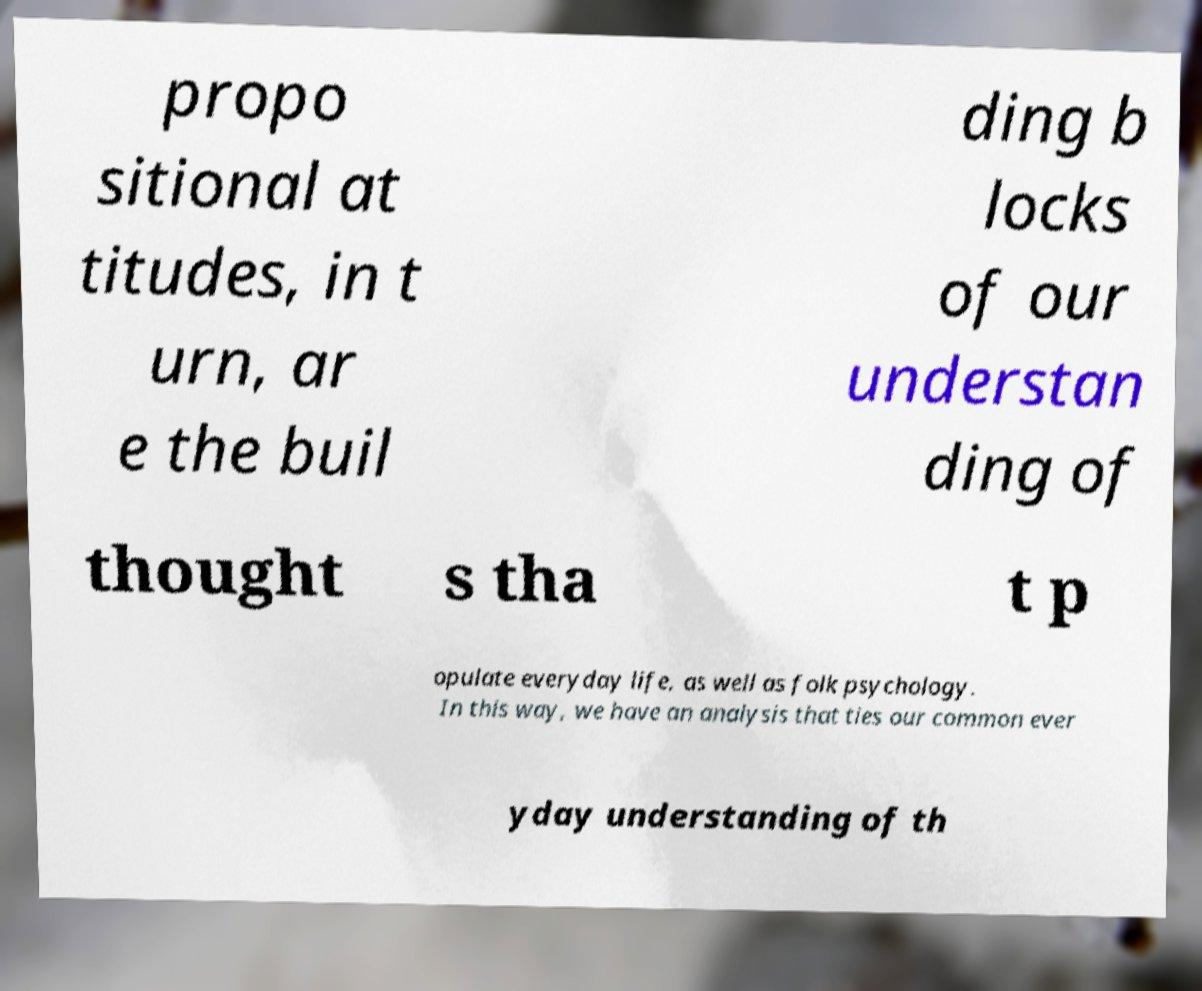Can you accurately transcribe the text from the provided image for me? propo sitional at titudes, in t urn, ar e the buil ding b locks of our understan ding of thought s tha t p opulate everyday life, as well as folk psychology. In this way, we have an analysis that ties our common ever yday understanding of th 